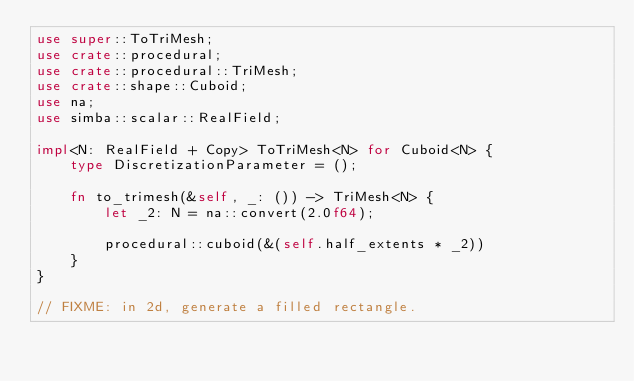<code> <loc_0><loc_0><loc_500><loc_500><_Rust_>use super::ToTriMesh;
use crate::procedural;
use crate::procedural::TriMesh;
use crate::shape::Cuboid;
use na;
use simba::scalar::RealField;

impl<N: RealField + Copy> ToTriMesh<N> for Cuboid<N> {
    type DiscretizationParameter = ();

    fn to_trimesh(&self, _: ()) -> TriMesh<N> {
        let _2: N = na::convert(2.0f64);

        procedural::cuboid(&(self.half_extents * _2))
    }
}

// FIXME: in 2d, generate a filled rectangle.
</code> 